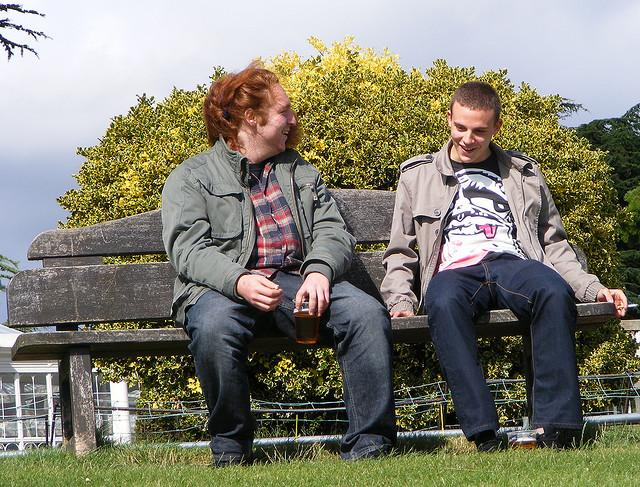What are the men sitting on? Please explain your reasoning. bench. The men are on a bench. 